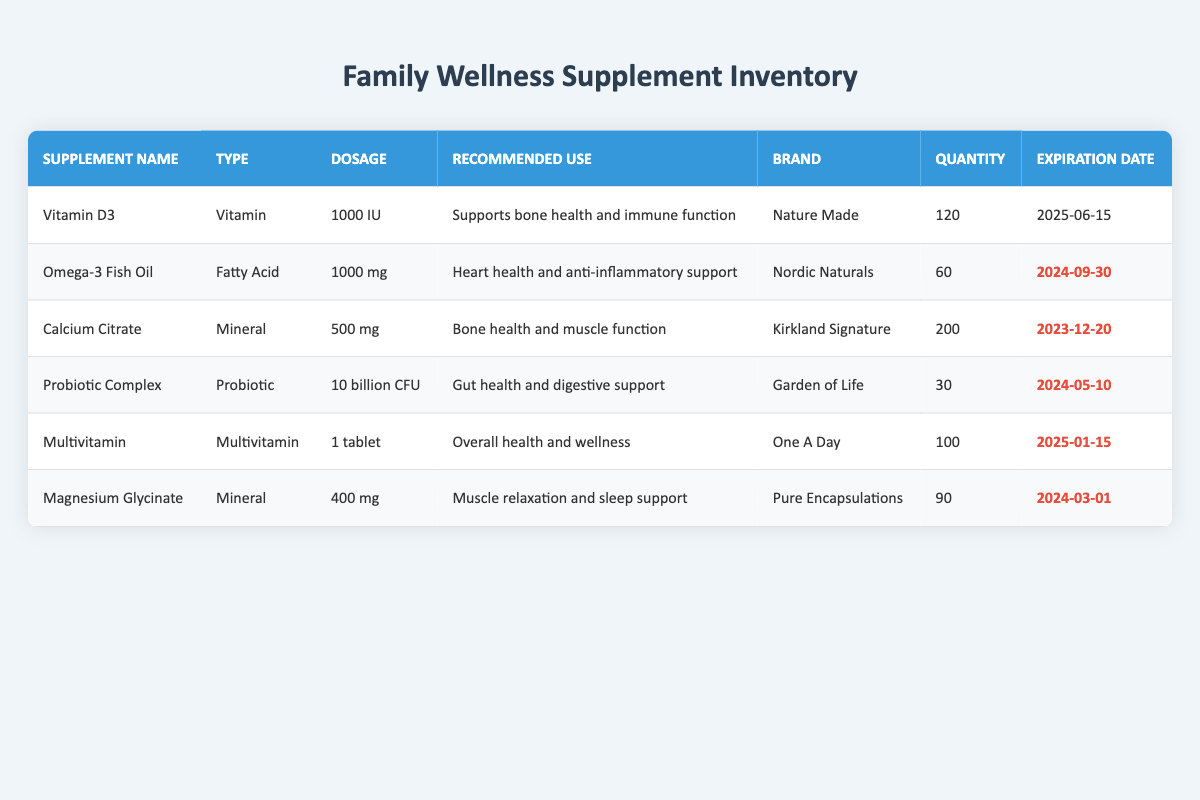What is the expiration date of Omega-3 Fish Oil? The expiration date is directly listed in the table in the last column for Omega-3 Fish Oil. According to the table, it is 2024-09-30.
Answer: 2024-09-30 How many Calcium Citrate supplements are available? The quantity of Calcium Citrate is given in the fourth column of the table. It shows that there are 200 available.
Answer: 200 Which supplement supports bone health and immune function? Referring to the recommended uses in the table, Vitamin D3 is listed under that category.
Answer: Vitamin D3 Is the Probiotic Complex expiring before 2024? To answer this, we check the expiration date for the Probiotic Complex in the table, which is 2024-05-10. Since this date is after 2024, the answer is no.
Answer: No What is the total quantity of supplements that expire within six months? We evaluate the expiration dates of the supplements. Calcium Citrate expires on 2023-12-20, and Multivitamin on 2025-01-15, making total that expire in six months: Calcium Citrate (200) = 200.
Answer: 200 Which type of supplement has the highest quantity listed? By comparing the quantities listed in the table, Calcium Citrate has the highest quantity of 200 while others have 120, 60, 30, and 90.
Answer: Calcium Citrate How many more doses of Magnesium Glycinate than Probiotic Complex are available? The dosage counts for Magnesium Glycinate is 90 and Probiotic Complex is 30. The difference is calculated as 90 - 30 = 60.
Answer: 60 Does the Multivitamin have a recommended usage for heart health? The recommended use for Multivitamin is overall health and wellness, which does not include heart health.
Answer: No How many different brands of supplements are listed in the table? By counting each unique brand in the table: Nature Made, Nordic Naturals, Kirkland Signature, Garden of Life, One A Day, and Pure Encapsulations, we find there are six distinct brands.
Answer: 6 